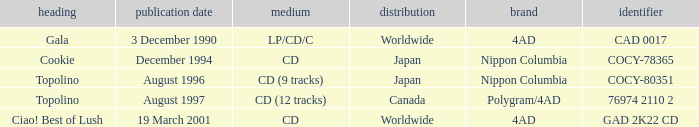What Label has a Code of cocy-78365? Nippon Columbia. 